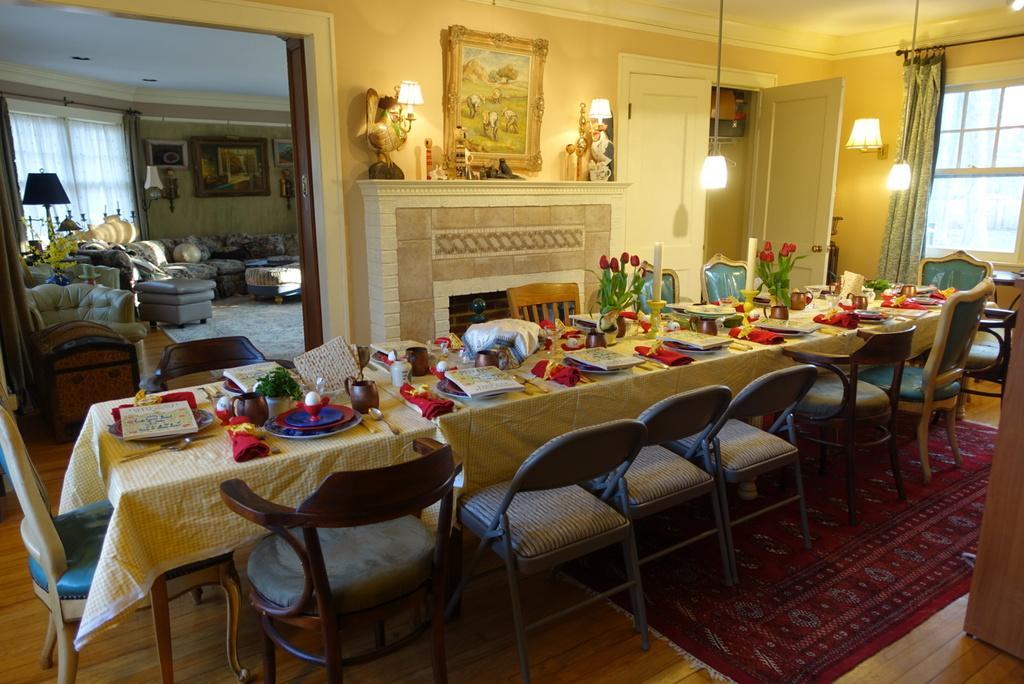Could you give a brief overview of what you see in this image? In this image we can see a group of chairs placed on the ground. In the foreground of the image we can see some plates, books, cups, some flowers and some objects placed on the table. In the right side of the image we can see windows, lights and some curtains. In the center of the image we can see some lamps and objects placed on the shelf and some photo frames on the wall. On the left side of the image we can see a container placed on the ground. 